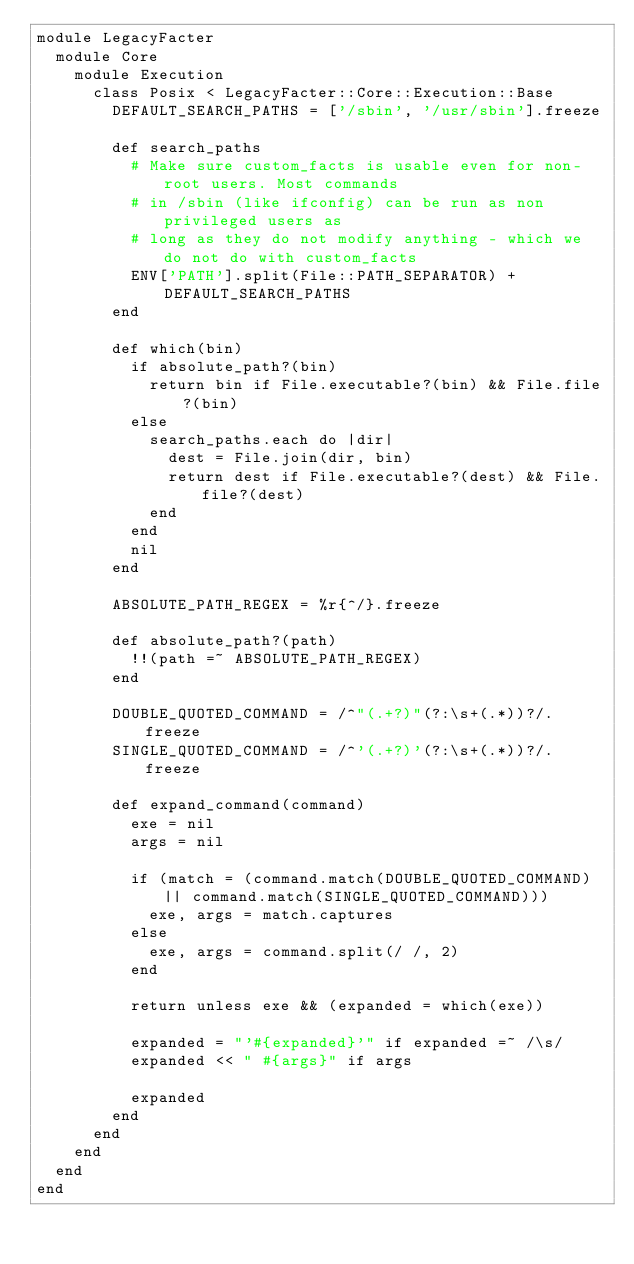<code> <loc_0><loc_0><loc_500><loc_500><_Ruby_>module LegacyFacter
  module Core
    module Execution
      class Posix < LegacyFacter::Core::Execution::Base
        DEFAULT_SEARCH_PATHS = ['/sbin', '/usr/sbin'].freeze

        def search_paths
          # Make sure custom_facts is usable even for non-root users. Most commands
          # in /sbin (like ifconfig) can be run as non privileged users as
          # long as they do not modify anything - which we do not do with custom_facts
          ENV['PATH'].split(File::PATH_SEPARATOR) + DEFAULT_SEARCH_PATHS
        end

        def which(bin)
          if absolute_path?(bin)
            return bin if File.executable?(bin) && File.file?(bin)
          else
            search_paths.each do |dir|
              dest = File.join(dir, bin)
              return dest if File.executable?(dest) && File.file?(dest)
            end
          end
          nil
        end

        ABSOLUTE_PATH_REGEX = %r{^/}.freeze

        def absolute_path?(path)
          !!(path =~ ABSOLUTE_PATH_REGEX)
        end

        DOUBLE_QUOTED_COMMAND = /^"(.+?)"(?:\s+(.*))?/.freeze
        SINGLE_QUOTED_COMMAND = /^'(.+?)'(?:\s+(.*))?/.freeze

        def expand_command(command)
          exe = nil
          args = nil

          if (match = (command.match(DOUBLE_QUOTED_COMMAND) || command.match(SINGLE_QUOTED_COMMAND)))
            exe, args = match.captures
          else
            exe, args = command.split(/ /, 2)
          end

          return unless exe && (expanded = which(exe))

          expanded = "'#{expanded}'" if expanded =~ /\s/
          expanded << " #{args}" if args

          expanded
        end
      end
    end
  end
end
</code> 